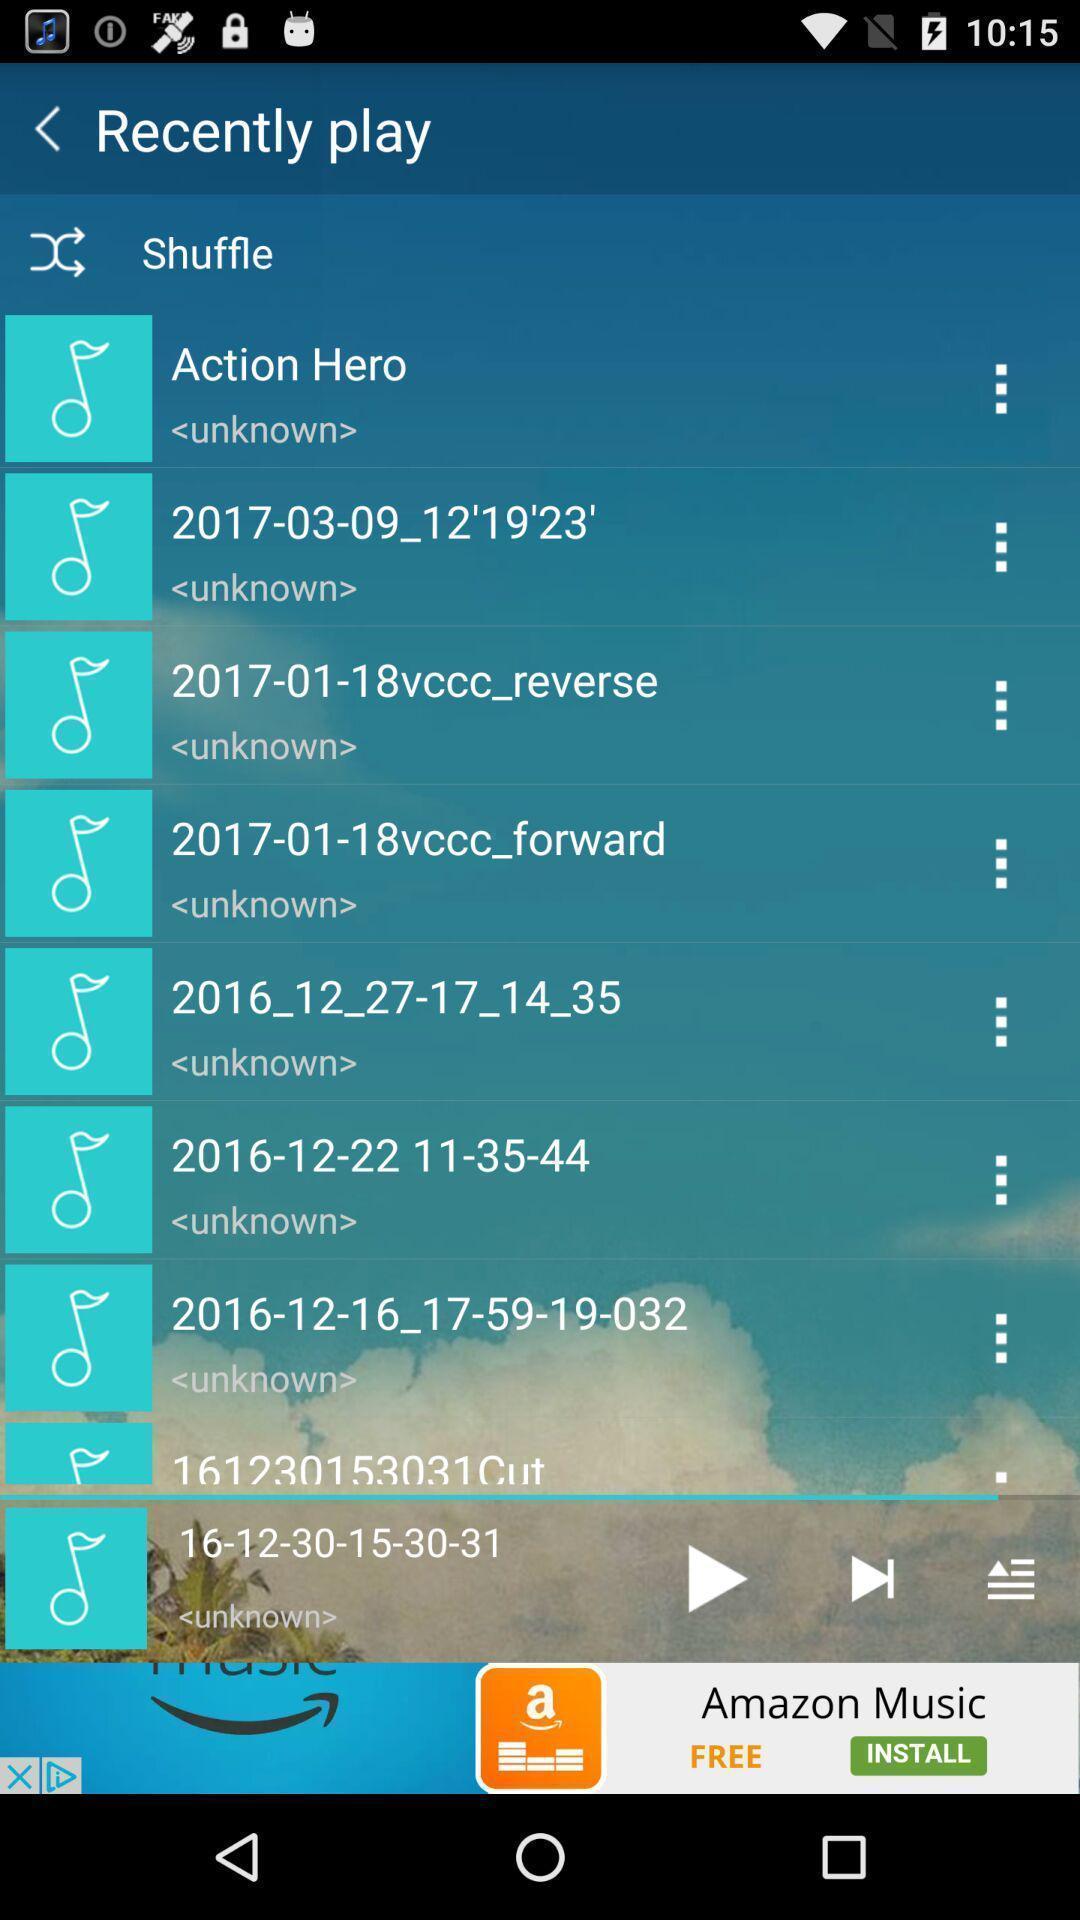Describe the content in this image. Page showing list of songs in a music player. 